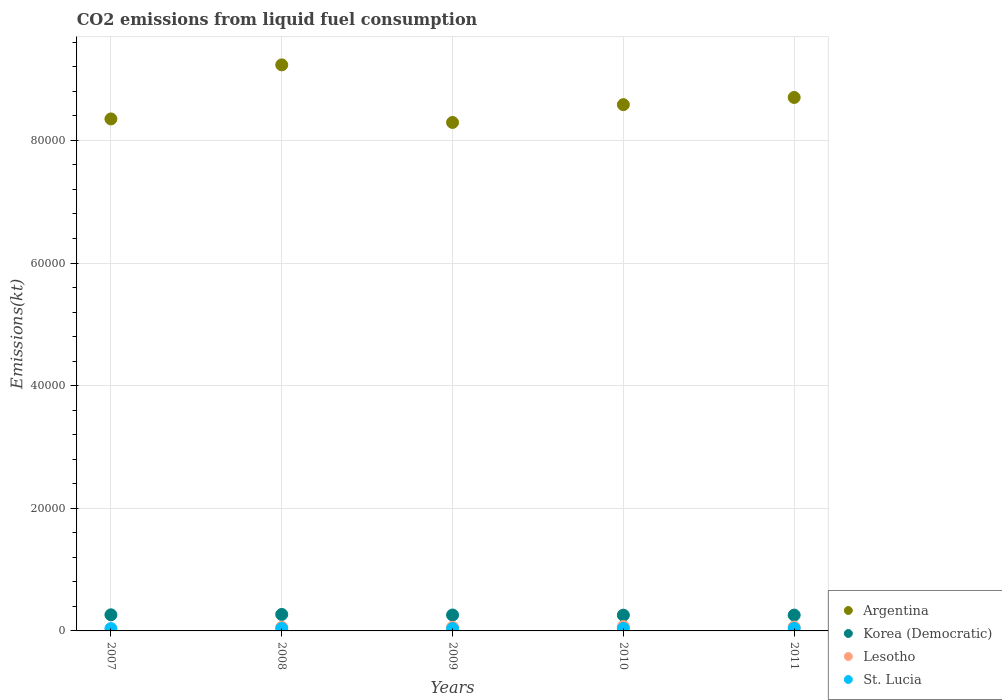Is the number of dotlines equal to the number of legend labels?
Make the answer very short. Yes. What is the amount of CO2 emitted in St. Lucia in 2009?
Give a very brief answer. 385.04. Across all years, what is the maximum amount of CO2 emitted in St. Lucia?
Offer a terse response. 407.04. Across all years, what is the minimum amount of CO2 emitted in Argentina?
Your answer should be compact. 8.29e+04. In which year was the amount of CO2 emitted in Lesotho maximum?
Your response must be concise. 2010. What is the total amount of CO2 emitted in Korea (Democratic) in the graph?
Make the answer very short. 1.31e+04. What is the difference between the amount of CO2 emitted in Argentina in 2008 and that in 2010?
Make the answer very short. 6486.92. What is the difference between the amount of CO2 emitted in Lesotho in 2010 and the amount of CO2 emitted in St. Lucia in 2007?
Your response must be concise. 330.03. What is the average amount of CO2 emitted in St. Lucia per year?
Your answer should be compact. 395.3. In the year 2010, what is the difference between the amount of CO2 emitted in Korea (Democratic) and amount of CO2 emitted in St. Lucia?
Ensure brevity in your answer.  2167.2. In how many years, is the amount of CO2 emitted in Argentina greater than 80000 kt?
Your answer should be compact. 5. Is the amount of CO2 emitted in Korea (Democratic) in 2008 less than that in 2009?
Your response must be concise. No. Is the difference between the amount of CO2 emitted in Korea (Democratic) in 2007 and 2010 greater than the difference between the amount of CO2 emitted in St. Lucia in 2007 and 2010?
Provide a succinct answer. Yes. What is the difference between the highest and the second highest amount of CO2 emitted in St. Lucia?
Provide a short and direct response. 3.67. What is the difference between the highest and the lowest amount of CO2 emitted in Korea (Democratic)?
Ensure brevity in your answer.  117.34. In how many years, is the amount of CO2 emitted in St. Lucia greater than the average amount of CO2 emitted in St. Lucia taken over all years?
Offer a terse response. 3. Is it the case that in every year, the sum of the amount of CO2 emitted in Lesotho and amount of CO2 emitted in St. Lucia  is greater than the sum of amount of CO2 emitted in Korea (Democratic) and amount of CO2 emitted in Argentina?
Give a very brief answer. No. Does the amount of CO2 emitted in Argentina monotonically increase over the years?
Your response must be concise. No. Is the amount of CO2 emitted in Lesotho strictly greater than the amount of CO2 emitted in Korea (Democratic) over the years?
Make the answer very short. No. How many dotlines are there?
Offer a very short reply. 4. How many years are there in the graph?
Give a very brief answer. 5. Does the graph contain any zero values?
Provide a short and direct response. No. Does the graph contain grids?
Offer a terse response. Yes. Where does the legend appear in the graph?
Offer a terse response. Bottom right. How are the legend labels stacked?
Offer a very short reply. Vertical. What is the title of the graph?
Offer a very short reply. CO2 emissions from liquid fuel consumption. What is the label or title of the Y-axis?
Provide a short and direct response. Emissions(kt). What is the Emissions(kt) of Argentina in 2007?
Keep it short and to the point. 8.35e+04. What is the Emissions(kt) of Korea (Democratic) in 2007?
Offer a very short reply. 2625.57. What is the Emissions(kt) in Lesotho in 2007?
Keep it short and to the point. 7.33. What is the Emissions(kt) of St. Lucia in 2007?
Provide a succinct answer. 385.04. What is the Emissions(kt) of Argentina in 2008?
Your response must be concise. 9.23e+04. What is the Emissions(kt) of Korea (Democratic) in 2008?
Your response must be concise. 2687.91. What is the Emissions(kt) in Lesotho in 2008?
Your answer should be compact. 586.72. What is the Emissions(kt) of St. Lucia in 2008?
Offer a terse response. 396.04. What is the Emissions(kt) of Argentina in 2009?
Your response must be concise. 8.29e+04. What is the Emissions(kt) in Korea (Democratic) in 2009?
Provide a succinct answer. 2592.57. What is the Emissions(kt) of Lesotho in 2009?
Offer a very short reply. 594.05. What is the Emissions(kt) in St. Lucia in 2009?
Provide a succinct answer. 385.04. What is the Emissions(kt) of Argentina in 2010?
Your answer should be compact. 8.58e+04. What is the Emissions(kt) of Korea (Democratic) in 2010?
Offer a terse response. 2570.57. What is the Emissions(kt) in Lesotho in 2010?
Provide a succinct answer. 715.07. What is the Emissions(kt) in St. Lucia in 2010?
Your response must be concise. 403.37. What is the Emissions(kt) of Argentina in 2011?
Give a very brief answer. 8.70e+04. What is the Emissions(kt) in Korea (Democratic) in 2011?
Your answer should be very brief. 2581.57. What is the Emissions(kt) of Lesotho in 2011?
Offer a very short reply. 630.72. What is the Emissions(kt) of St. Lucia in 2011?
Provide a succinct answer. 407.04. Across all years, what is the maximum Emissions(kt) of Argentina?
Provide a succinct answer. 9.23e+04. Across all years, what is the maximum Emissions(kt) of Korea (Democratic)?
Give a very brief answer. 2687.91. Across all years, what is the maximum Emissions(kt) of Lesotho?
Keep it short and to the point. 715.07. Across all years, what is the maximum Emissions(kt) in St. Lucia?
Keep it short and to the point. 407.04. Across all years, what is the minimum Emissions(kt) of Argentina?
Offer a very short reply. 8.29e+04. Across all years, what is the minimum Emissions(kt) of Korea (Democratic)?
Make the answer very short. 2570.57. Across all years, what is the minimum Emissions(kt) of Lesotho?
Ensure brevity in your answer.  7.33. Across all years, what is the minimum Emissions(kt) of St. Lucia?
Your answer should be compact. 385.04. What is the total Emissions(kt) of Argentina in the graph?
Provide a succinct answer. 4.32e+05. What is the total Emissions(kt) of Korea (Democratic) in the graph?
Give a very brief answer. 1.31e+04. What is the total Emissions(kt) of Lesotho in the graph?
Your answer should be compact. 2533.9. What is the total Emissions(kt) in St. Lucia in the graph?
Your response must be concise. 1976.51. What is the difference between the Emissions(kt) of Argentina in 2007 and that in 2008?
Provide a short and direct response. -8815.47. What is the difference between the Emissions(kt) of Korea (Democratic) in 2007 and that in 2008?
Your answer should be very brief. -62.34. What is the difference between the Emissions(kt) of Lesotho in 2007 and that in 2008?
Give a very brief answer. -579.39. What is the difference between the Emissions(kt) of St. Lucia in 2007 and that in 2008?
Ensure brevity in your answer.  -11. What is the difference between the Emissions(kt) of Argentina in 2007 and that in 2009?
Provide a short and direct response. 575.72. What is the difference between the Emissions(kt) in Korea (Democratic) in 2007 and that in 2009?
Provide a short and direct response. 33. What is the difference between the Emissions(kt) in Lesotho in 2007 and that in 2009?
Make the answer very short. -586.72. What is the difference between the Emissions(kt) in Argentina in 2007 and that in 2010?
Give a very brief answer. -2328.55. What is the difference between the Emissions(kt) of Korea (Democratic) in 2007 and that in 2010?
Your answer should be very brief. 55.01. What is the difference between the Emissions(kt) in Lesotho in 2007 and that in 2010?
Your answer should be very brief. -707.73. What is the difference between the Emissions(kt) of St. Lucia in 2007 and that in 2010?
Make the answer very short. -18.34. What is the difference between the Emissions(kt) in Argentina in 2007 and that in 2011?
Give a very brief answer. -3501.99. What is the difference between the Emissions(kt) of Korea (Democratic) in 2007 and that in 2011?
Ensure brevity in your answer.  44. What is the difference between the Emissions(kt) of Lesotho in 2007 and that in 2011?
Ensure brevity in your answer.  -623.39. What is the difference between the Emissions(kt) of St. Lucia in 2007 and that in 2011?
Offer a terse response. -22. What is the difference between the Emissions(kt) in Argentina in 2008 and that in 2009?
Make the answer very short. 9391.19. What is the difference between the Emissions(kt) of Korea (Democratic) in 2008 and that in 2009?
Your answer should be compact. 95.34. What is the difference between the Emissions(kt) in Lesotho in 2008 and that in 2009?
Make the answer very short. -7.33. What is the difference between the Emissions(kt) in St. Lucia in 2008 and that in 2009?
Provide a succinct answer. 11. What is the difference between the Emissions(kt) of Argentina in 2008 and that in 2010?
Your answer should be compact. 6486.92. What is the difference between the Emissions(kt) of Korea (Democratic) in 2008 and that in 2010?
Your answer should be very brief. 117.34. What is the difference between the Emissions(kt) in Lesotho in 2008 and that in 2010?
Your answer should be very brief. -128.34. What is the difference between the Emissions(kt) in St. Lucia in 2008 and that in 2010?
Provide a short and direct response. -7.33. What is the difference between the Emissions(kt) in Argentina in 2008 and that in 2011?
Offer a very short reply. 5313.48. What is the difference between the Emissions(kt) of Korea (Democratic) in 2008 and that in 2011?
Your response must be concise. 106.34. What is the difference between the Emissions(kt) of Lesotho in 2008 and that in 2011?
Offer a very short reply. -44. What is the difference between the Emissions(kt) of St. Lucia in 2008 and that in 2011?
Give a very brief answer. -11. What is the difference between the Emissions(kt) in Argentina in 2009 and that in 2010?
Provide a succinct answer. -2904.26. What is the difference between the Emissions(kt) of Korea (Democratic) in 2009 and that in 2010?
Offer a very short reply. 22. What is the difference between the Emissions(kt) of Lesotho in 2009 and that in 2010?
Offer a very short reply. -121.01. What is the difference between the Emissions(kt) of St. Lucia in 2009 and that in 2010?
Make the answer very short. -18.34. What is the difference between the Emissions(kt) of Argentina in 2009 and that in 2011?
Offer a very short reply. -4077.7. What is the difference between the Emissions(kt) of Korea (Democratic) in 2009 and that in 2011?
Ensure brevity in your answer.  11. What is the difference between the Emissions(kt) in Lesotho in 2009 and that in 2011?
Your answer should be compact. -36.67. What is the difference between the Emissions(kt) in St. Lucia in 2009 and that in 2011?
Make the answer very short. -22. What is the difference between the Emissions(kt) in Argentina in 2010 and that in 2011?
Offer a very short reply. -1173.44. What is the difference between the Emissions(kt) in Korea (Democratic) in 2010 and that in 2011?
Provide a short and direct response. -11. What is the difference between the Emissions(kt) in Lesotho in 2010 and that in 2011?
Your answer should be compact. 84.34. What is the difference between the Emissions(kt) in St. Lucia in 2010 and that in 2011?
Keep it short and to the point. -3.67. What is the difference between the Emissions(kt) in Argentina in 2007 and the Emissions(kt) in Korea (Democratic) in 2008?
Your answer should be compact. 8.08e+04. What is the difference between the Emissions(kt) in Argentina in 2007 and the Emissions(kt) in Lesotho in 2008?
Offer a terse response. 8.29e+04. What is the difference between the Emissions(kt) of Argentina in 2007 and the Emissions(kt) of St. Lucia in 2008?
Ensure brevity in your answer.  8.31e+04. What is the difference between the Emissions(kt) of Korea (Democratic) in 2007 and the Emissions(kt) of Lesotho in 2008?
Your answer should be compact. 2038.85. What is the difference between the Emissions(kt) of Korea (Democratic) in 2007 and the Emissions(kt) of St. Lucia in 2008?
Your answer should be very brief. 2229.54. What is the difference between the Emissions(kt) of Lesotho in 2007 and the Emissions(kt) of St. Lucia in 2008?
Give a very brief answer. -388.7. What is the difference between the Emissions(kt) of Argentina in 2007 and the Emissions(kt) of Korea (Democratic) in 2009?
Your answer should be compact. 8.09e+04. What is the difference between the Emissions(kt) of Argentina in 2007 and the Emissions(kt) of Lesotho in 2009?
Ensure brevity in your answer.  8.29e+04. What is the difference between the Emissions(kt) in Argentina in 2007 and the Emissions(kt) in St. Lucia in 2009?
Your answer should be compact. 8.31e+04. What is the difference between the Emissions(kt) of Korea (Democratic) in 2007 and the Emissions(kt) of Lesotho in 2009?
Keep it short and to the point. 2031.52. What is the difference between the Emissions(kt) in Korea (Democratic) in 2007 and the Emissions(kt) in St. Lucia in 2009?
Make the answer very short. 2240.54. What is the difference between the Emissions(kt) of Lesotho in 2007 and the Emissions(kt) of St. Lucia in 2009?
Your answer should be compact. -377.7. What is the difference between the Emissions(kt) of Argentina in 2007 and the Emissions(kt) of Korea (Democratic) in 2010?
Your response must be concise. 8.09e+04. What is the difference between the Emissions(kt) of Argentina in 2007 and the Emissions(kt) of Lesotho in 2010?
Provide a succinct answer. 8.28e+04. What is the difference between the Emissions(kt) in Argentina in 2007 and the Emissions(kt) in St. Lucia in 2010?
Make the answer very short. 8.31e+04. What is the difference between the Emissions(kt) in Korea (Democratic) in 2007 and the Emissions(kt) in Lesotho in 2010?
Keep it short and to the point. 1910.51. What is the difference between the Emissions(kt) of Korea (Democratic) in 2007 and the Emissions(kt) of St. Lucia in 2010?
Your answer should be compact. 2222.2. What is the difference between the Emissions(kt) of Lesotho in 2007 and the Emissions(kt) of St. Lucia in 2010?
Make the answer very short. -396.04. What is the difference between the Emissions(kt) of Argentina in 2007 and the Emissions(kt) of Korea (Democratic) in 2011?
Give a very brief answer. 8.09e+04. What is the difference between the Emissions(kt) of Argentina in 2007 and the Emissions(kt) of Lesotho in 2011?
Your answer should be very brief. 8.29e+04. What is the difference between the Emissions(kt) of Argentina in 2007 and the Emissions(kt) of St. Lucia in 2011?
Give a very brief answer. 8.31e+04. What is the difference between the Emissions(kt) of Korea (Democratic) in 2007 and the Emissions(kt) of Lesotho in 2011?
Your answer should be compact. 1994.85. What is the difference between the Emissions(kt) of Korea (Democratic) in 2007 and the Emissions(kt) of St. Lucia in 2011?
Keep it short and to the point. 2218.53. What is the difference between the Emissions(kt) of Lesotho in 2007 and the Emissions(kt) of St. Lucia in 2011?
Make the answer very short. -399.7. What is the difference between the Emissions(kt) of Argentina in 2008 and the Emissions(kt) of Korea (Democratic) in 2009?
Provide a short and direct response. 8.97e+04. What is the difference between the Emissions(kt) of Argentina in 2008 and the Emissions(kt) of Lesotho in 2009?
Keep it short and to the point. 9.17e+04. What is the difference between the Emissions(kt) of Argentina in 2008 and the Emissions(kt) of St. Lucia in 2009?
Make the answer very short. 9.19e+04. What is the difference between the Emissions(kt) in Korea (Democratic) in 2008 and the Emissions(kt) in Lesotho in 2009?
Give a very brief answer. 2093.86. What is the difference between the Emissions(kt) in Korea (Democratic) in 2008 and the Emissions(kt) in St. Lucia in 2009?
Your answer should be very brief. 2302.88. What is the difference between the Emissions(kt) in Lesotho in 2008 and the Emissions(kt) in St. Lucia in 2009?
Offer a terse response. 201.69. What is the difference between the Emissions(kt) in Argentina in 2008 and the Emissions(kt) in Korea (Democratic) in 2010?
Give a very brief answer. 8.97e+04. What is the difference between the Emissions(kt) of Argentina in 2008 and the Emissions(kt) of Lesotho in 2010?
Ensure brevity in your answer.  9.16e+04. What is the difference between the Emissions(kt) of Argentina in 2008 and the Emissions(kt) of St. Lucia in 2010?
Provide a short and direct response. 9.19e+04. What is the difference between the Emissions(kt) of Korea (Democratic) in 2008 and the Emissions(kt) of Lesotho in 2010?
Provide a short and direct response. 1972.85. What is the difference between the Emissions(kt) in Korea (Democratic) in 2008 and the Emissions(kt) in St. Lucia in 2010?
Your answer should be compact. 2284.54. What is the difference between the Emissions(kt) of Lesotho in 2008 and the Emissions(kt) of St. Lucia in 2010?
Offer a very short reply. 183.35. What is the difference between the Emissions(kt) in Argentina in 2008 and the Emissions(kt) in Korea (Democratic) in 2011?
Offer a very short reply. 8.97e+04. What is the difference between the Emissions(kt) of Argentina in 2008 and the Emissions(kt) of Lesotho in 2011?
Your response must be concise. 9.17e+04. What is the difference between the Emissions(kt) of Argentina in 2008 and the Emissions(kt) of St. Lucia in 2011?
Your response must be concise. 9.19e+04. What is the difference between the Emissions(kt) in Korea (Democratic) in 2008 and the Emissions(kt) in Lesotho in 2011?
Provide a short and direct response. 2057.19. What is the difference between the Emissions(kt) in Korea (Democratic) in 2008 and the Emissions(kt) in St. Lucia in 2011?
Offer a very short reply. 2280.87. What is the difference between the Emissions(kt) of Lesotho in 2008 and the Emissions(kt) of St. Lucia in 2011?
Offer a terse response. 179.68. What is the difference between the Emissions(kt) in Argentina in 2009 and the Emissions(kt) in Korea (Democratic) in 2010?
Your response must be concise. 8.04e+04. What is the difference between the Emissions(kt) of Argentina in 2009 and the Emissions(kt) of Lesotho in 2010?
Ensure brevity in your answer.  8.22e+04. What is the difference between the Emissions(kt) of Argentina in 2009 and the Emissions(kt) of St. Lucia in 2010?
Make the answer very short. 8.25e+04. What is the difference between the Emissions(kt) of Korea (Democratic) in 2009 and the Emissions(kt) of Lesotho in 2010?
Ensure brevity in your answer.  1877.5. What is the difference between the Emissions(kt) in Korea (Democratic) in 2009 and the Emissions(kt) in St. Lucia in 2010?
Offer a terse response. 2189.2. What is the difference between the Emissions(kt) in Lesotho in 2009 and the Emissions(kt) in St. Lucia in 2010?
Give a very brief answer. 190.68. What is the difference between the Emissions(kt) of Argentina in 2009 and the Emissions(kt) of Korea (Democratic) in 2011?
Your answer should be compact. 8.03e+04. What is the difference between the Emissions(kt) in Argentina in 2009 and the Emissions(kt) in Lesotho in 2011?
Your response must be concise. 8.23e+04. What is the difference between the Emissions(kt) of Argentina in 2009 and the Emissions(kt) of St. Lucia in 2011?
Provide a short and direct response. 8.25e+04. What is the difference between the Emissions(kt) in Korea (Democratic) in 2009 and the Emissions(kt) in Lesotho in 2011?
Keep it short and to the point. 1961.85. What is the difference between the Emissions(kt) in Korea (Democratic) in 2009 and the Emissions(kt) in St. Lucia in 2011?
Your answer should be very brief. 2185.53. What is the difference between the Emissions(kt) of Lesotho in 2009 and the Emissions(kt) of St. Lucia in 2011?
Keep it short and to the point. 187.02. What is the difference between the Emissions(kt) of Argentina in 2010 and the Emissions(kt) of Korea (Democratic) in 2011?
Give a very brief answer. 8.32e+04. What is the difference between the Emissions(kt) in Argentina in 2010 and the Emissions(kt) in Lesotho in 2011?
Ensure brevity in your answer.  8.52e+04. What is the difference between the Emissions(kt) in Argentina in 2010 and the Emissions(kt) in St. Lucia in 2011?
Offer a terse response. 8.54e+04. What is the difference between the Emissions(kt) of Korea (Democratic) in 2010 and the Emissions(kt) of Lesotho in 2011?
Your answer should be very brief. 1939.84. What is the difference between the Emissions(kt) in Korea (Democratic) in 2010 and the Emissions(kt) in St. Lucia in 2011?
Provide a short and direct response. 2163.53. What is the difference between the Emissions(kt) in Lesotho in 2010 and the Emissions(kt) in St. Lucia in 2011?
Your answer should be compact. 308.03. What is the average Emissions(kt) of Argentina per year?
Give a very brief answer. 8.63e+04. What is the average Emissions(kt) of Korea (Democratic) per year?
Your response must be concise. 2611.64. What is the average Emissions(kt) of Lesotho per year?
Give a very brief answer. 506.78. What is the average Emissions(kt) of St. Lucia per year?
Offer a very short reply. 395.3. In the year 2007, what is the difference between the Emissions(kt) in Argentina and Emissions(kt) in Korea (Democratic)?
Ensure brevity in your answer.  8.09e+04. In the year 2007, what is the difference between the Emissions(kt) in Argentina and Emissions(kt) in Lesotho?
Keep it short and to the point. 8.35e+04. In the year 2007, what is the difference between the Emissions(kt) of Argentina and Emissions(kt) of St. Lucia?
Ensure brevity in your answer.  8.31e+04. In the year 2007, what is the difference between the Emissions(kt) of Korea (Democratic) and Emissions(kt) of Lesotho?
Offer a very short reply. 2618.24. In the year 2007, what is the difference between the Emissions(kt) of Korea (Democratic) and Emissions(kt) of St. Lucia?
Give a very brief answer. 2240.54. In the year 2007, what is the difference between the Emissions(kt) of Lesotho and Emissions(kt) of St. Lucia?
Your response must be concise. -377.7. In the year 2008, what is the difference between the Emissions(kt) in Argentina and Emissions(kt) in Korea (Democratic)?
Your response must be concise. 8.96e+04. In the year 2008, what is the difference between the Emissions(kt) in Argentina and Emissions(kt) in Lesotho?
Keep it short and to the point. 9.17e+04. In the year 2008, what is the difference between the Emissions(kt) in Argentina and Emissions(kt) in St. Lucia?
Your answer should be compact. 9.19e+04. In the year 2008, what is the difference between the Emissions(kt) in Korea (Democratic) and Emissions(kt) in Lesotho?
Make the answer very short. 2101.19. In the year 2008, what is the difference between the Emissions(kt) of Korea (Democratic) and Emissions(kt) of St. Lucia?
Your answer should be very brief. 2291.88. In the year 2008, what is the difference between the Emissions(kt) of Lesotho and Emissions(kt) of St. Lucia?
Offer a terse response. 190.68. In the year 2009, what is the difference between the Emissions(kt) in Argentina and Emissions(kt) in Korea (Democratic)?
Give a very brief answer. 8.03e+04. In the year 2009, what is the difference between the Emissions(kt) of Argentina and Emissions(kt) of Lesotho?
Offer a very short reply. 8.23e+04. In the year 2009, what is the difference between the Emissions(kt) of Argentina and Emissions(kt) of St. Lucia?
Offer a very short reply. 8.25e+04. In the year 2009, what is the difference between the Emissions(kt) in Korea (Democratic) and Emissions(kt) in Lesotho?
Make the answer very short. 1998.52. In the year 2009, what is the difference between the Emissions(kt) of Korea (Democratic) and Emissions(kt) of St. Lucia?
Offer a very short reply. 2207.53. In the year 2009, what is the difference between the Emissions(kt) of Lesotho and Emissions(kt) of St. Lucia?
Your response must be concise. 209.02. In the year 2010, what is the difference between the Emissions(kt) in Argentina and Emissions(kt) in Korea (Democratic)?
Your answer should be very brief. 8.33e+04. In the year 2010, what is the difference between the Emissions(kt) of Argentina and Emissions(kt) of Lesotho?
Make the answer very short. 8.51e+04. In the year 2010, what is the difference between the Emissions(kt) of Argentina and Emissions(kt) of St. Lucia?
Your response must be concise. 8.54e+04. In the year 2010, what is the difference between the Emissions(kt) in Korea (Democratic) and Emissions(kt) in Lesotho?
Provide a short and direct response. 1855.5. In the year 2010, what is the difference between the Emissions(kt) in Korea (Democratic) and Emissions(kt) in St. Lucia?
Provide a succinct answer. 2167.2. In the year 2010, what is the difference between the Emissions(kt) of Lesotho and Emissions(kt) of St. Lucia?
Your answer should be compact. 311.69. In the year 2011, what is the difference between the Emissions(kt) in Argentina and Emissions(kt) in Korea (Democratic)?
Ensure brevity in your answer.  8.44e+04. In the year 2011, what is the difference between the Emissions(kt) of Argentina and Emissions(kt) of Lesotho?
Offer a terse response. 8.64e+04. In the year 2011, what is the difference between the Emissions(kt) of Argentina and Emissions(kt) of St. Lucia?
Your answer should be compact. 8.66e+04. In the year 2011, what is the difference between the Emissions(kt) of Korea (Democratic) and Emissions(kt) of Lesotho?
Your answer should be compact. 1950.84. In the year 2011, what is the difference between the Emissions(kt) of Korea (Democratic) and Emissions(kt) of St. Lucia?
Your answer should be very brief. 2174.53. In the year 2011, what is the difference between the Emissions(kt) in Lesotho and Emissions(kt) in St. Lucia?
Ensure brevity in your answer.  223.69. What is the ratio of the Emissions(kt) in Argentina in 2007 to that in 2008?
Provide a short and direct response. 0.9. What is the ratio of the Emissions(kt) of Korea (Democratic) in 2007 to that in 2008?
Your answer should be very brief. 0.98. What is the ratio of the Emissions(kt) of Lesotho in 2007 to that in 2008?
Make the answer very short. 0.01. What is the ratio of the Emissions(kt) in St. Lucia in 2007 to that in 2008?
Offer a terse response. 0.97. What is the ratio of the Emissions(kt) in Argentina in 2007 to that in 2009?
Offer a very short reply. 1.01. What is the ratio of the Emissions(kt) of Korea (Democratic) in 2007 to that in 2009?
Your answer should be compact. 1.01. What is the ratio of the Emissions(kt) in Lesotho in 2007 to that in 2009?
Your answer should be very brief. 0.01. What is the ratio of the Emissions(kt) in Argentina in 2007 to that in 2010?
Ensure brevity in your answer.  0.97. What is the ratio of the Emissions(kt) of Korea (Democratic) in 2007 to that in 2010?
Provide a succinct answer. 1.02. What is the ratio of the Emissions(kt) in Lesotho in 2007 to that in 2010?
Offer a terse response. 0.01. What is the ratio of the Emissions(kt) in St. Lucia in 2007 to that in 2010?
Provide a short and direct response. 0.95. What is the ratio of the Emissions(kt) of Argentina in 2007 to that in 2011?
Offer a very short reply. 0.96. What is the ratio of the Emissions(kt) in Korea (Democratic) in 2007 to that in 2011?
Your response must be concise. 1.02. What is the ratio of the Emissions(kt) of Lesotho in 2007 to that in 2011?
Give a very brief answer. 0.01. What is the ratio of the Emissions(kt) in St. Lucia in 2007 to that in 2011?
Offer a terse response. 0.95. What is the ratio of the Emissions(kt) in Argentina in 2008 to that in 2009?
Your answer should be compact. 1.11. What is the ratio of the Emissions(kt) in Korea (Democratic) in 2008 to that in 2009?
Your response must be concise. 1.04. What is the ratio of the Emissions(kt) in Lesotho in 2008 to that in 2009?
Ensure brevity in your answer.  0.99. What is the ratio of the Emissions(kt) in St. Lucia in 2008 to that in 2009?
Offer a very short reply. 1.03. What is the ratio of the Emissions(kt) in Argentina in 2008 to that in 2010?
Your answer should be compact. 1.08. What is the ratio of the Emissions(kt) of Korea (Democratic) in 2008 to that in 2010?
Keep it short and to the point. 1.05. What is the ratio of the Emissions(kt) of Lesotho in 2008 to that in 2010?
Your response must be concise. 0.82. What is the ratio of the Emissions(kt) of St. Lucia in 2008 to that in 2010?
Make the answer very short. 0.98. What is the ratio of the Emissions(kt) in Argentina in 2008 to that in 2011?
Make the answer very short. 1.06. What is the ratio of the Emissions(kt) in Korea (Democratic) in 2008 to that in 2011?
Your response must be concise. 1.04. What is the ratio of the Emissions(kt) in Lesotho in 2008 to that in 2011?
Your answer should be compact. 0.93. What is the ratio of the Emissions(kt) in Argentina in 2009 to that in 2010?
Offer a terse response. 0.97. What is the ratio of the Emissions(kt) in Korea (Democratic) in 2009 to that in 2010?
Your answer should be very brief. 1.01. What is the ratio of the Emissions(kt) of Lesotho in 2009 to that in 2010?
Ensure brevity in your answer.  0.83. What is the ratio of the Emissions(kt) in St. Lucia in 2009 to that in 2010?
Make the answer very short. 0.95. What is the ratio of the Emissions(kt) in Argentina in 2009 to that in 2011?
Provide a short and direct response. 0.95. What is the ratio of the Emissions(kt) of Lesotho in 2009 to that in 2011?
Offer a terse response. 0.94. What is the ratio of the Emissions(kt) in St. Lucia in 2009 to that in 2011?
Give a very brief answer. 0.95. What is the ratio of the Emissions(kt) of Argentina in 2010 to that in 2011?
Provide a succinct answer. 0.99. What is the ratio of the Emissions(kt) of Korea (Democratic) in 2010 to that in 2011?
Your response must be concise. 1. What is the ratio of the Emissions(kt) in Lesotho in 2010 to that in 2011?
Provide a short and direct response. 1.13. What is the difference between the highest and the second highest Emissions(kt) of Argentina?
Ensure brevity in your answer.  5313.48. What is the difference between the highest and the second highest Emissions(kt) in Korea (Democratic)?
Your answer should be compact. 62.34. What is the difference between the highest and the second highest Emissions(kt) of Lesotho?
Ensure brevity in your answer.  84.34. What is the difference between the highest and the second highest Emissions(kt) in St. Lucia?
Provide a short and direct response. 3.67. What is the difference between the highest and the lowest Emissions(kt) of Argentina?
Give a very brief answer. 9391.19. What is the difference between the highest and the lowest Emissions(kt) in Korea (Democratic)?
Make the answer very short. 117.34. What is the difference between the highest and the lowest Emissions(kt) in Lesotho?
Keep it short and to the point. 707.73. What is the difference between the highest and the lowest Emissions(kt) of St. Lucia?
Ensure brevity in your answer.  22. 